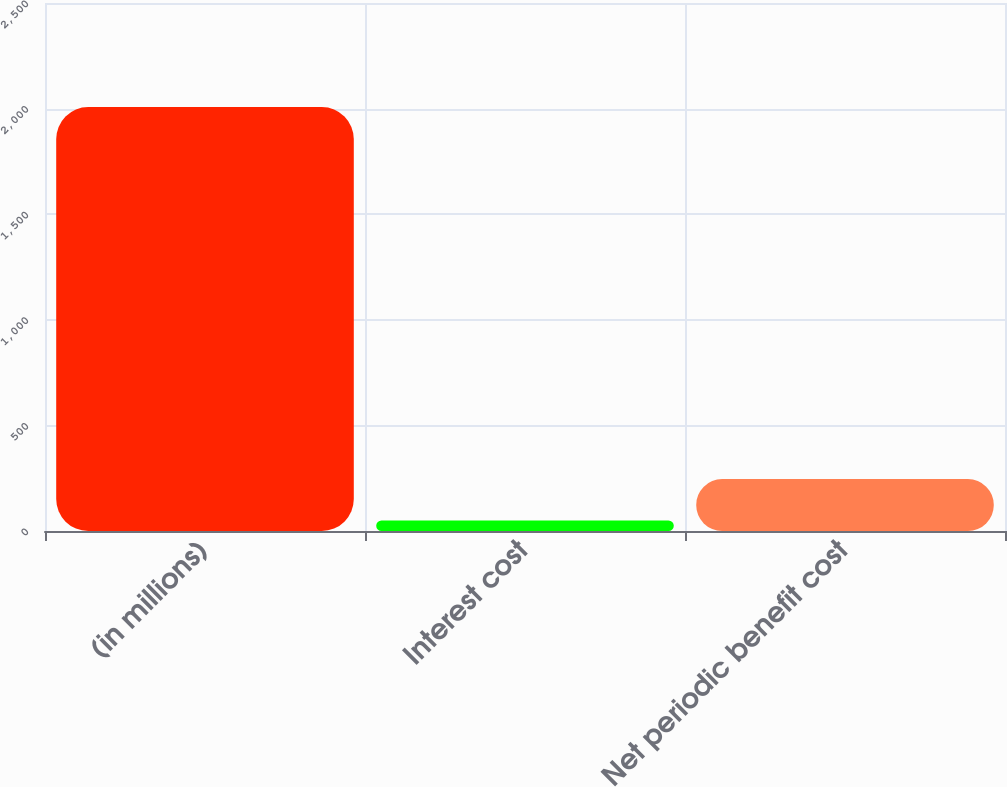Convert chart to OTSL. <chart><loc_0><loc_0><loc_500><loc_500><bar_chart><fcel>(in millions)<fcel>Interest cost<fcel>Net periodic benefit cost<nl><fcel>2007<fcel>50<fcel>245.7<nl></chart> 